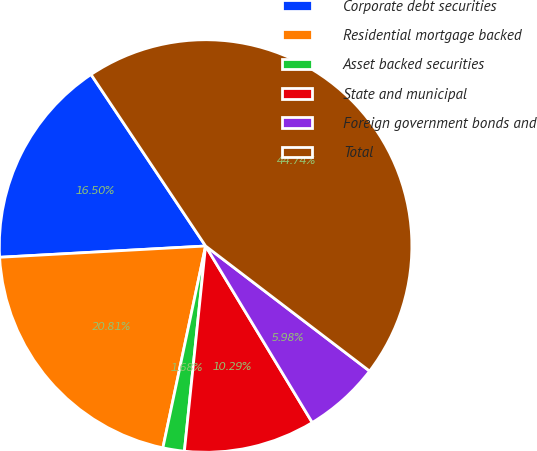<chart> <loc_0><loc_0><loc_500><loc_500><pie_chart><fcel>Corporate debt securities<fcel>Residential mortgage backed<fcel>Asset backed securities<fcel>State and municipal<fcel>Foreign government bonds and<fcel>Total<nl><fcel>16.5%<fcel>20.81%<fcel>1.68%<fcel>10.29%<fcel>5.98%<fcel>44.74%<nl></chart> 